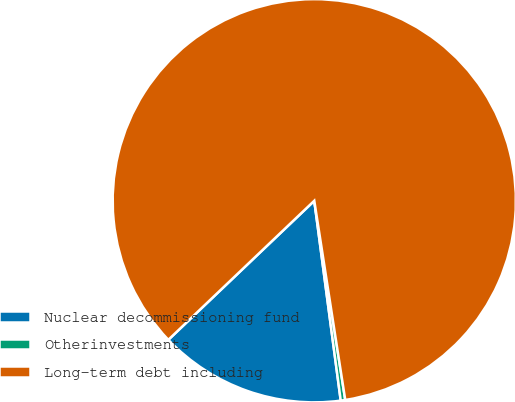Convert chart. <chart><loc_0><loc_0><loc_500><loc_500><pie_chart><fcel>Nuclear decommissioning fund<fcel>Otherinvestments<fcel>Long-term debt including<nl><fcel>14.98%<fcel>0.36%<fcel>84.66%<nl></chart> 